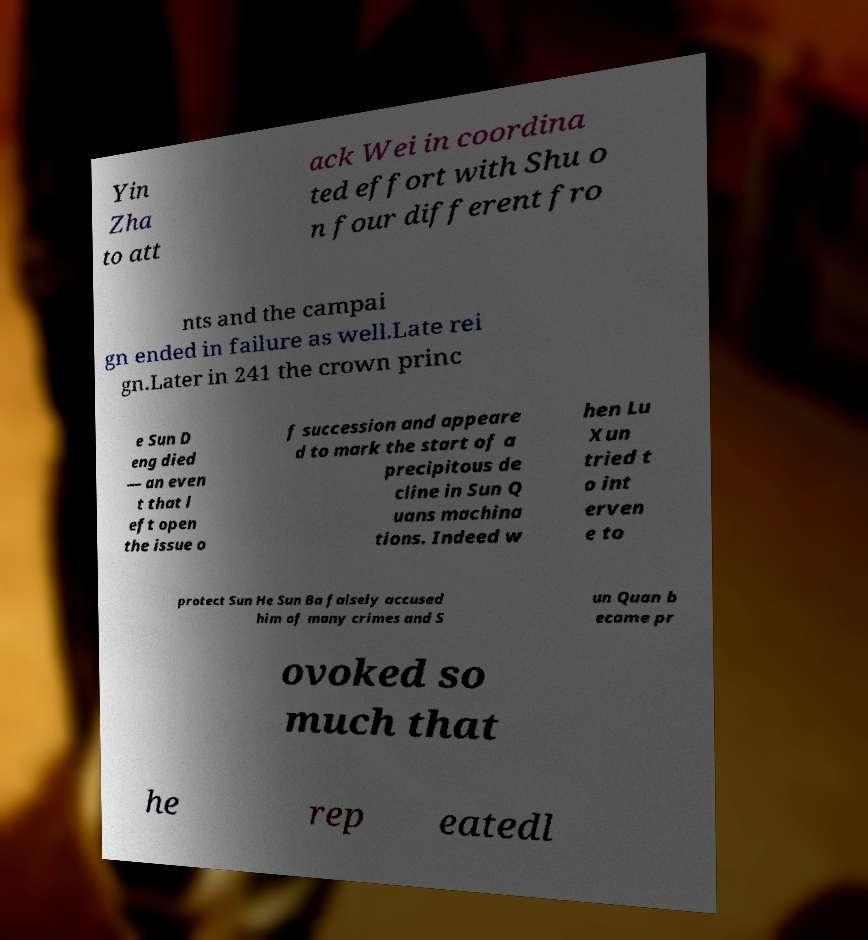What messages or text are displayed in this image? I need them in a readable, typed format. Yin Zha to att ack Wei in coordina ted effort with Shu o n four different fro nts and the campai gn ended in failure as well.Late rei gn.Later in 241 the crown princ e Sun D eng died — an even t that l eft open the issue o f succession and appeare d to mark the start of a precipitous de cline in Sun Q uans machina tions. Indeed w hen Lu Xun tried t o int erven e to protect Sun He Sun Ba falsely accused him of many crimes and S un Quan b ecame pr ovoked so much that he rep eatedl 